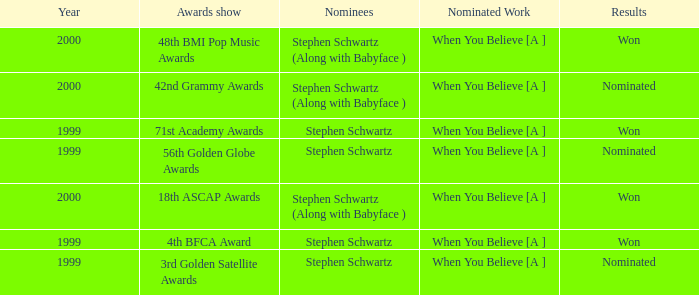What was the result in 2000? Won, Won, Nominated. 